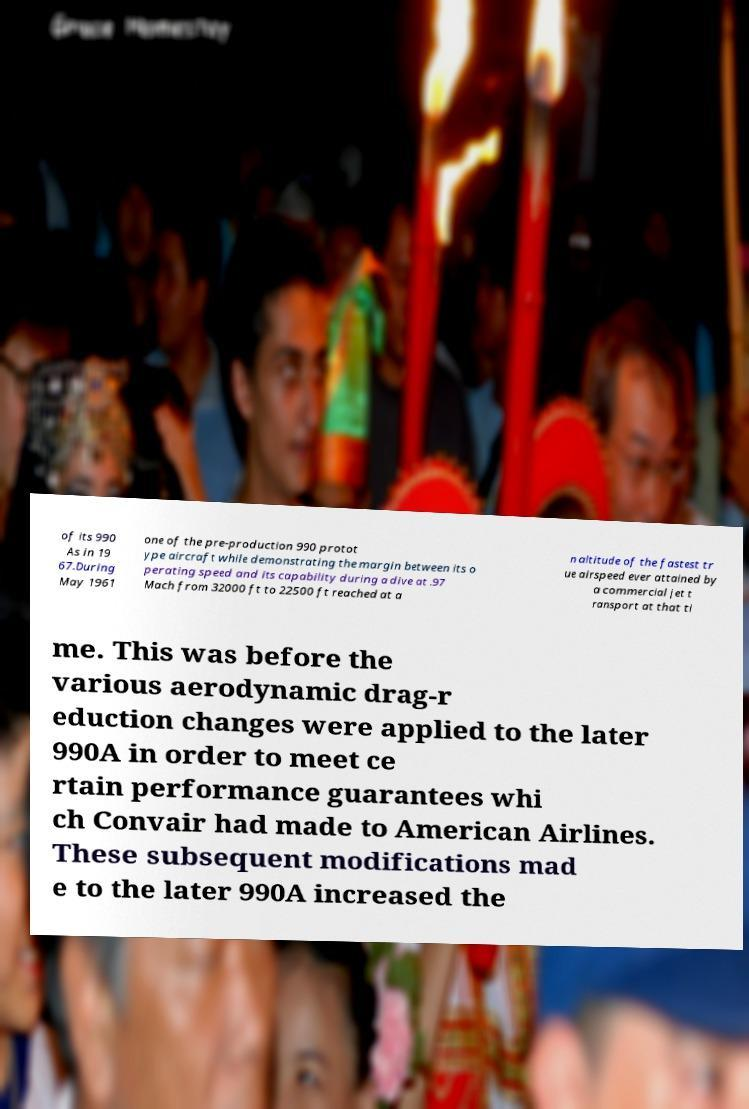Please identify and transcribe the text found in this image. of its 990 As in 19 67.During May 1961 one of the pre-production 990 protot ype aircraft while demonstrating the margin between its o perating speed and its capability during a dive at .97 Mach from 32000 ft to 22500 ft reached at a n altitude of the fastest tr ue airspeed ever attained by a commercial jet t ransport at that ti me. This was before the various aerodynamic drag-r eduction changes were applied to the later 990A in order to meet ce rtain performance guarantees whi ch Convair had made to American Airlines. These subsequent modifications mad e to the later 990A increased the 